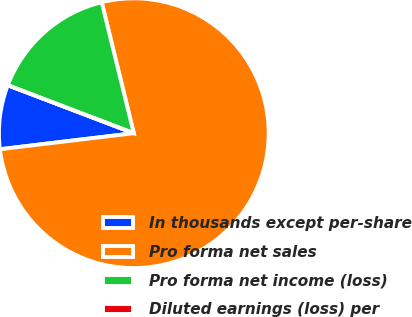Convert chart to OTSL. <chart><loc_0><loc_0><loc_500><loc_500><pie_chart><fcel>In thousands except per-share<fcel>Pro forma net sales<fcel>Pro forma net income (loss)<fcel>Diluted earnings (loss) per<nl><fcel>7.69%<fcel>76.92%<fcel>15.38%<fcel>0.0%<nl></chart> 